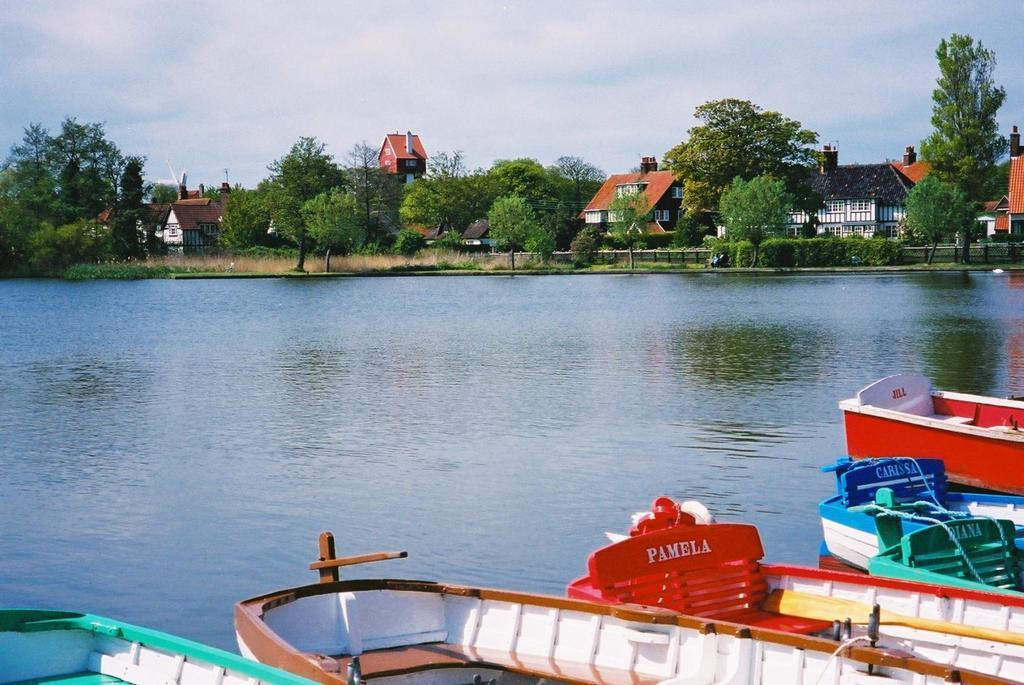Can you describe this image briefly? This image consists of boats. In the middle, there is water. In the background, we can see many trees and houses. At the top, there are clouds in the sky. 